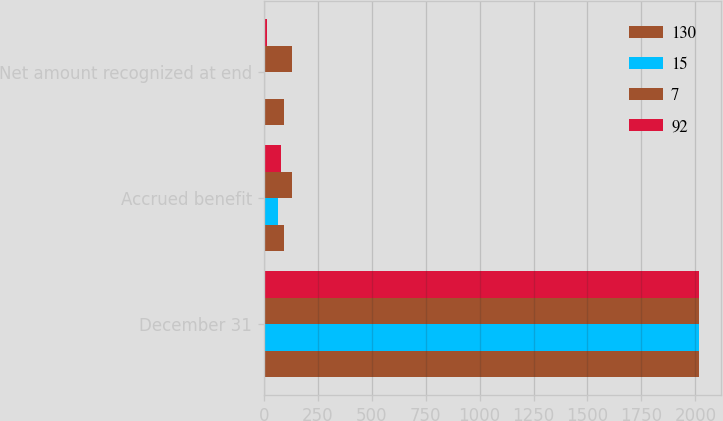<chart> <loc_0><loc_0><loc_500><loc_500><stacked_bar_chart><ecel><fcel>December 31<fcel>Accrued benefit<fcel>Net amount recognized at end<nl><fcel>130<fcel>2018<fcel>92<fcel>92<nl><fcel>15<fcel>2018<fcel>65<fcel>7<nl><fcel>7<fcel>2017<fcel>130<fcel>130<nl><fcel>92<fcel>2017<fcel>78<fcel>15<nl></chart> 